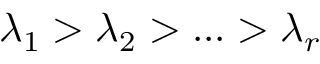<formula> <loc_0><loc_0><loc_500><loc_500>\lambda _ { 1 } > \lambda _ { 2 } > \dots > \lambda _ { r }</formula> 